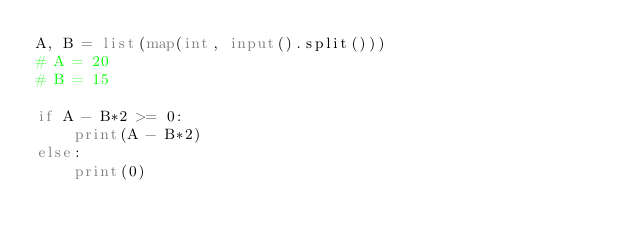<code> <loc_0><loc_0><loc_500><loc_500><_Python_>A, B = list(map(int, input().split()))
# A = 20
# B = 15

if A - B*2 >= 0:
    print(A - B*2)
else:
    print(0)</code> 